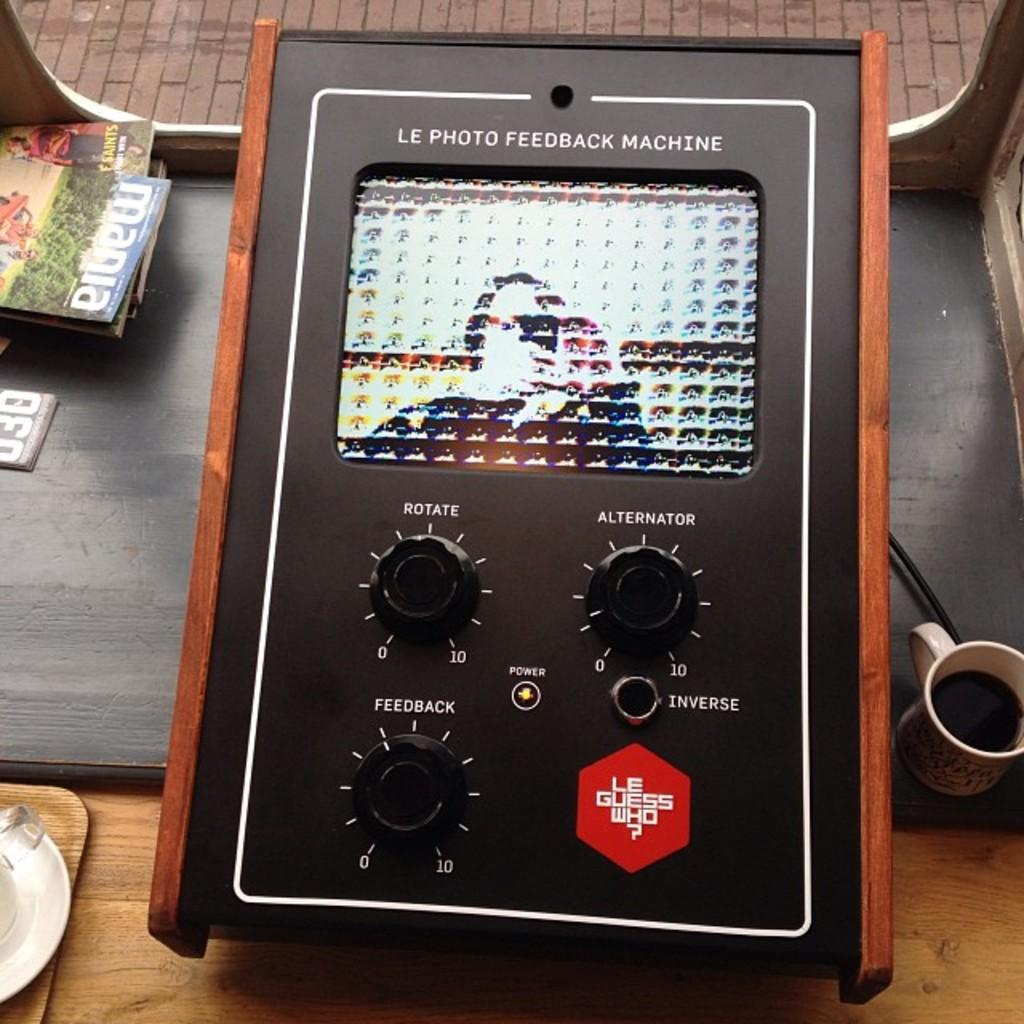Provide a one-sentence caption for the provided image. Le Photo Feedback Machine with black dials and wooden edges is on a table. 